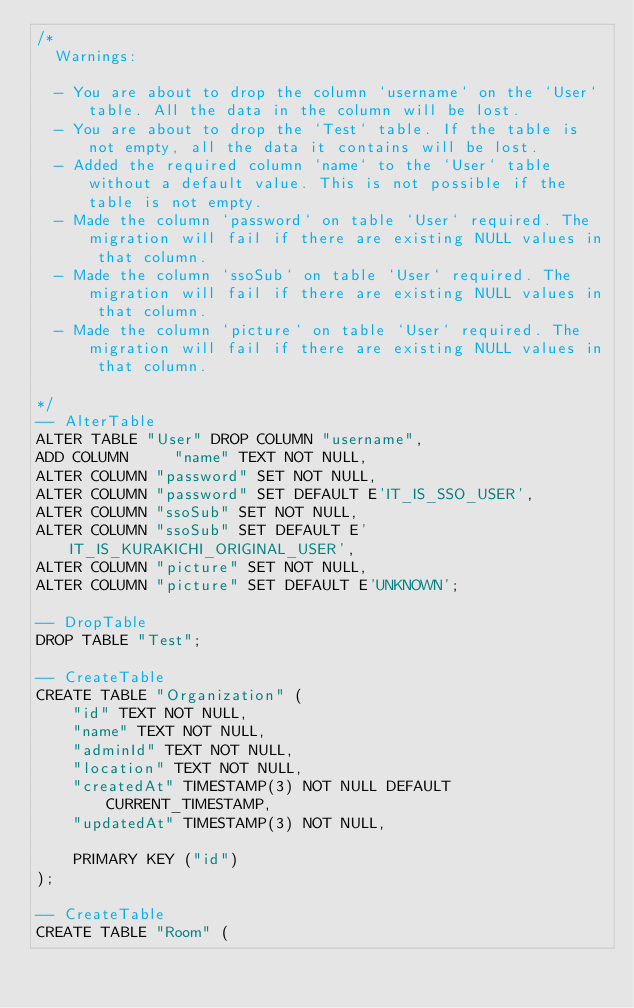<code> <loc_0><loc_0><loc_500><loc_500><_SQL_>/*
  Warnings:

  - You are about to drop the column `username` on the `User` table. All the data in the column will be lost.
  - You are about to drop the `Test` table. If the table is not empty, all the data it contains will be lost.
  - Added the required column `name` to the `User` table without a default value. This is not possible if the table is not empty.
  - Made the column `password` on table `User` required. The migration will fail if there are existing NULL values in that column.
  - Made the column `ssoSub` on table `User` required. The migration will fail if there are existing NULL values in that column.
  - Made the column `picture` on table `User` required. The migration will fail if there are existing NULL values in that column.

*/
-- AlterTable
ALTER TABLE "User" DROP COLUMN "username",
ADD COLUMN     "name" TEXT NOT NULL,
ALTER COLUMN "password" SET NOT NULL,
ALTER COLUMN "password" SET DEFAULT E'IT_IS_SSO_USER',
ALTER COLUMN "ssoSub" SET NOT NULL,
ALTER COLUMN "ssoSub" SET DEFAULT E'IT_IS_KURAKICHI_ORIGINAL_USER',
ALTER COLUMN "picture" SET NOT NULL,
ALTER COLUMN "picture" SET DEFAULT E'UNKNOWN';

-- DropTable
DROP TABLE "Test";

-- CreateTable
CREATE TABLE "Organization" (
    "id" TEXT NOT NULL,
    "name" TEXT NOT NULL,
    "adminId" TEXT NOT NULL,
    "location" TEXT NOT NULL,
    "createdAt" TIMESTAMP(3) NOT NULL DEFAULT CURRENT_TIMESTAMP,
    "updatedAt" TIMESTAMP(3) NOT NULL,

    PRIMARY KEY ("id")
);

-- CreateTable
CREATE TABLE "Room" (</code> 